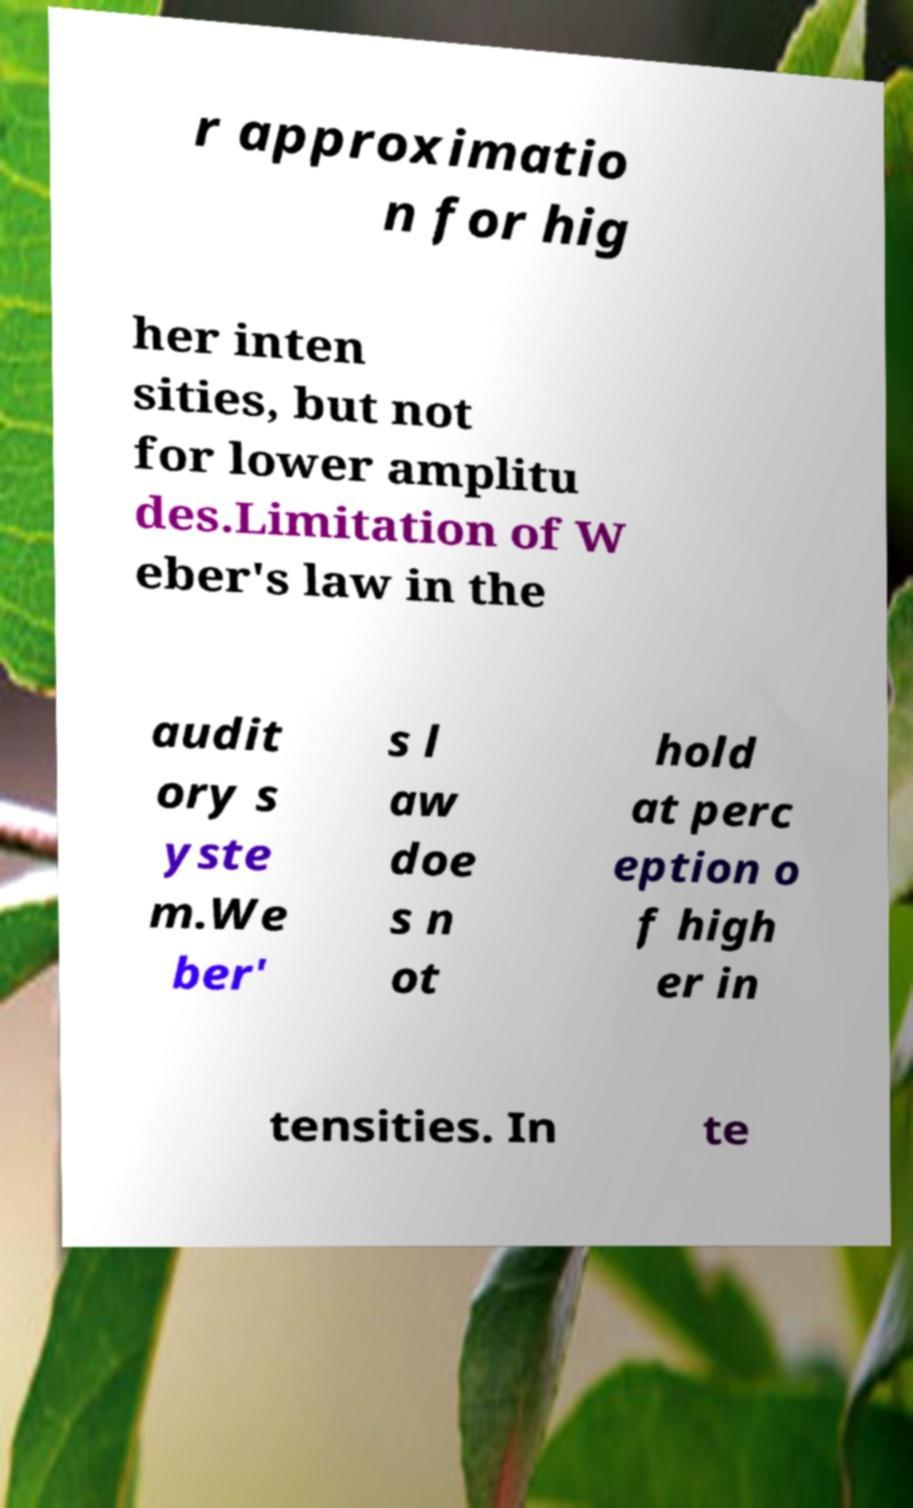Could you extract and type out the text from this image? r approximatio n for hig her inten sities, but not for lower amplitu des.Limitation of W eber's law in the audit ory s yste m.We ber' s l aw doe s n ot hold at perc eption o f high er in tensities. In te 